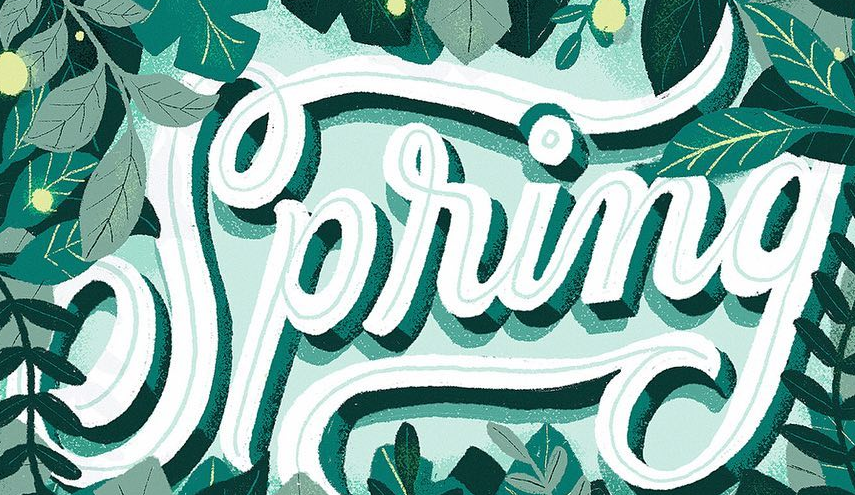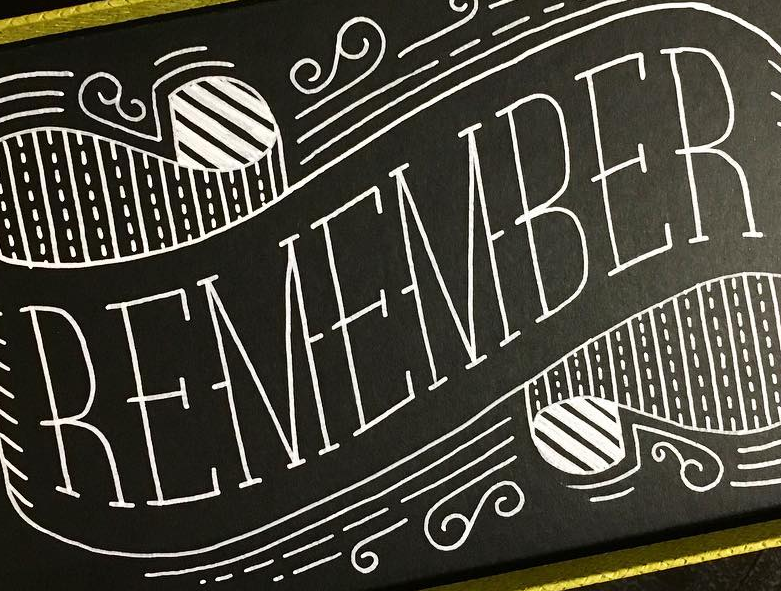Transcribe the words shown in these images in order, separated by a semicolon. Spring; REMEMBER 